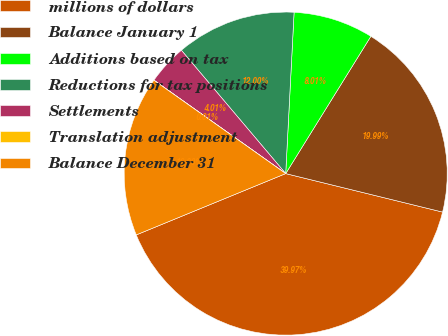<chart> <loc_0><loc_0><loc_500><loc_500><pie_chart><fcel>millions of dollars<fcel>Balance January 1<fcel>Additions based on tax<fcel>Reductions for tax positions<fcel>Settlements<fcel>Translation adjustment<fcel>Balance December 31<nl><fcel>39.97%<fcel>19.99%<fcel>8.01%<fcel>12.0%<fcel>4.01%<fcel>0.01%<fcel>16.0%<nl></chart> 